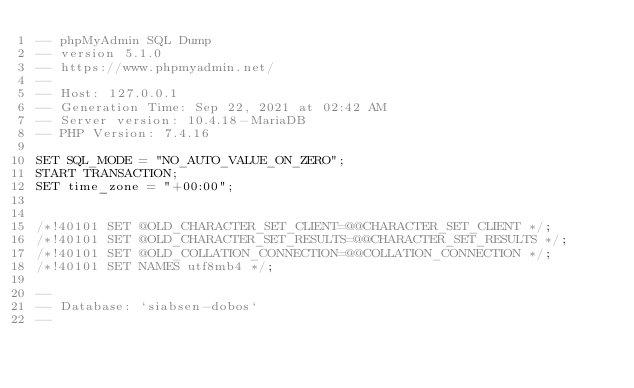Convert code to text. <code><loc_0><loc_0><loc_500><loc_500><_SQL_>-- phpMyAdmin SQL Dump
-- version 5.1.0
-- https://www.phpmyadmin.net/
--
-- Host: 127.0.0.1
-- Generation Time: Sep 22, 2021 at 02:42 AM
-- Server version: 10.4.18-MariaDB
-- PHP Version: 7.4.16

SET SQL_MODE = "NO_AUTO_VALUE_ON_ZERO";
START TRANSACTION;
SET time_zone = "+00:00";


/*!40101 SET @OLD_CHARACTER_SET_CLIENT=@@CHARACTER_SET_CLIENT */;
/*!40101 SET @OLD_CHARACTER_SET_RESULTS=@@CHARACTER_SET_RESULTS */;
/*!40101 SET @OLD_COLLATION_CONNECTION=@@COLLATION_CONNECTION */;
/*!40101 SET NAMES utf8mb4 */;

--
-- Database: `siabsen-dobos`
--
</code> 